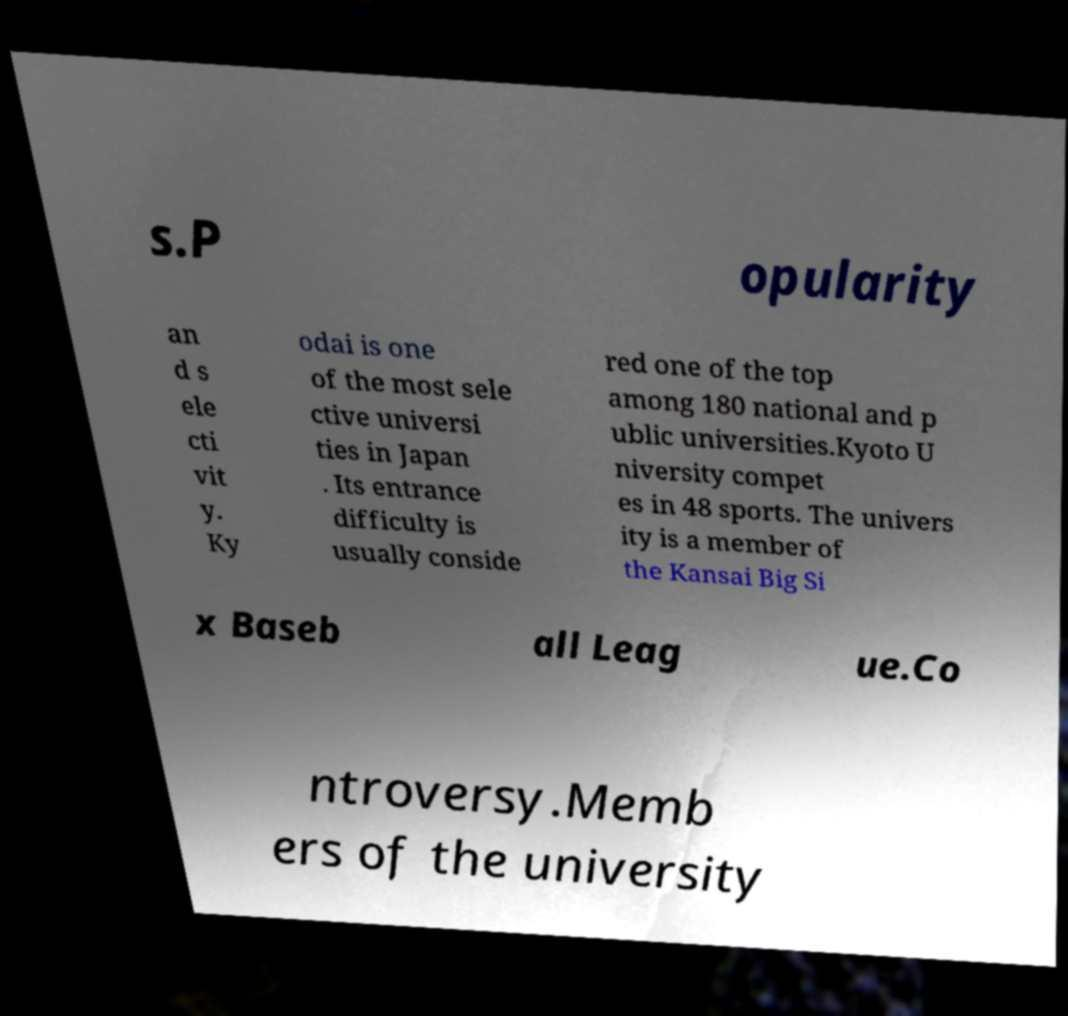There's text embedded in this image that I need extracted. Can you transcribe it verbatim? s.P opularity an d s ele cti vit y. Ky odai is one of the most sele ctive universi ties in Japan . Its entrance difficulty is usually conside red one of the top among 180 national and p ublic universities.Kyoto U niversity compet es in 48 sports. The univers ity is a member of the Kansai Big Si x Baseb all Leag ue.Co ntroversy.Memb ers of the university 